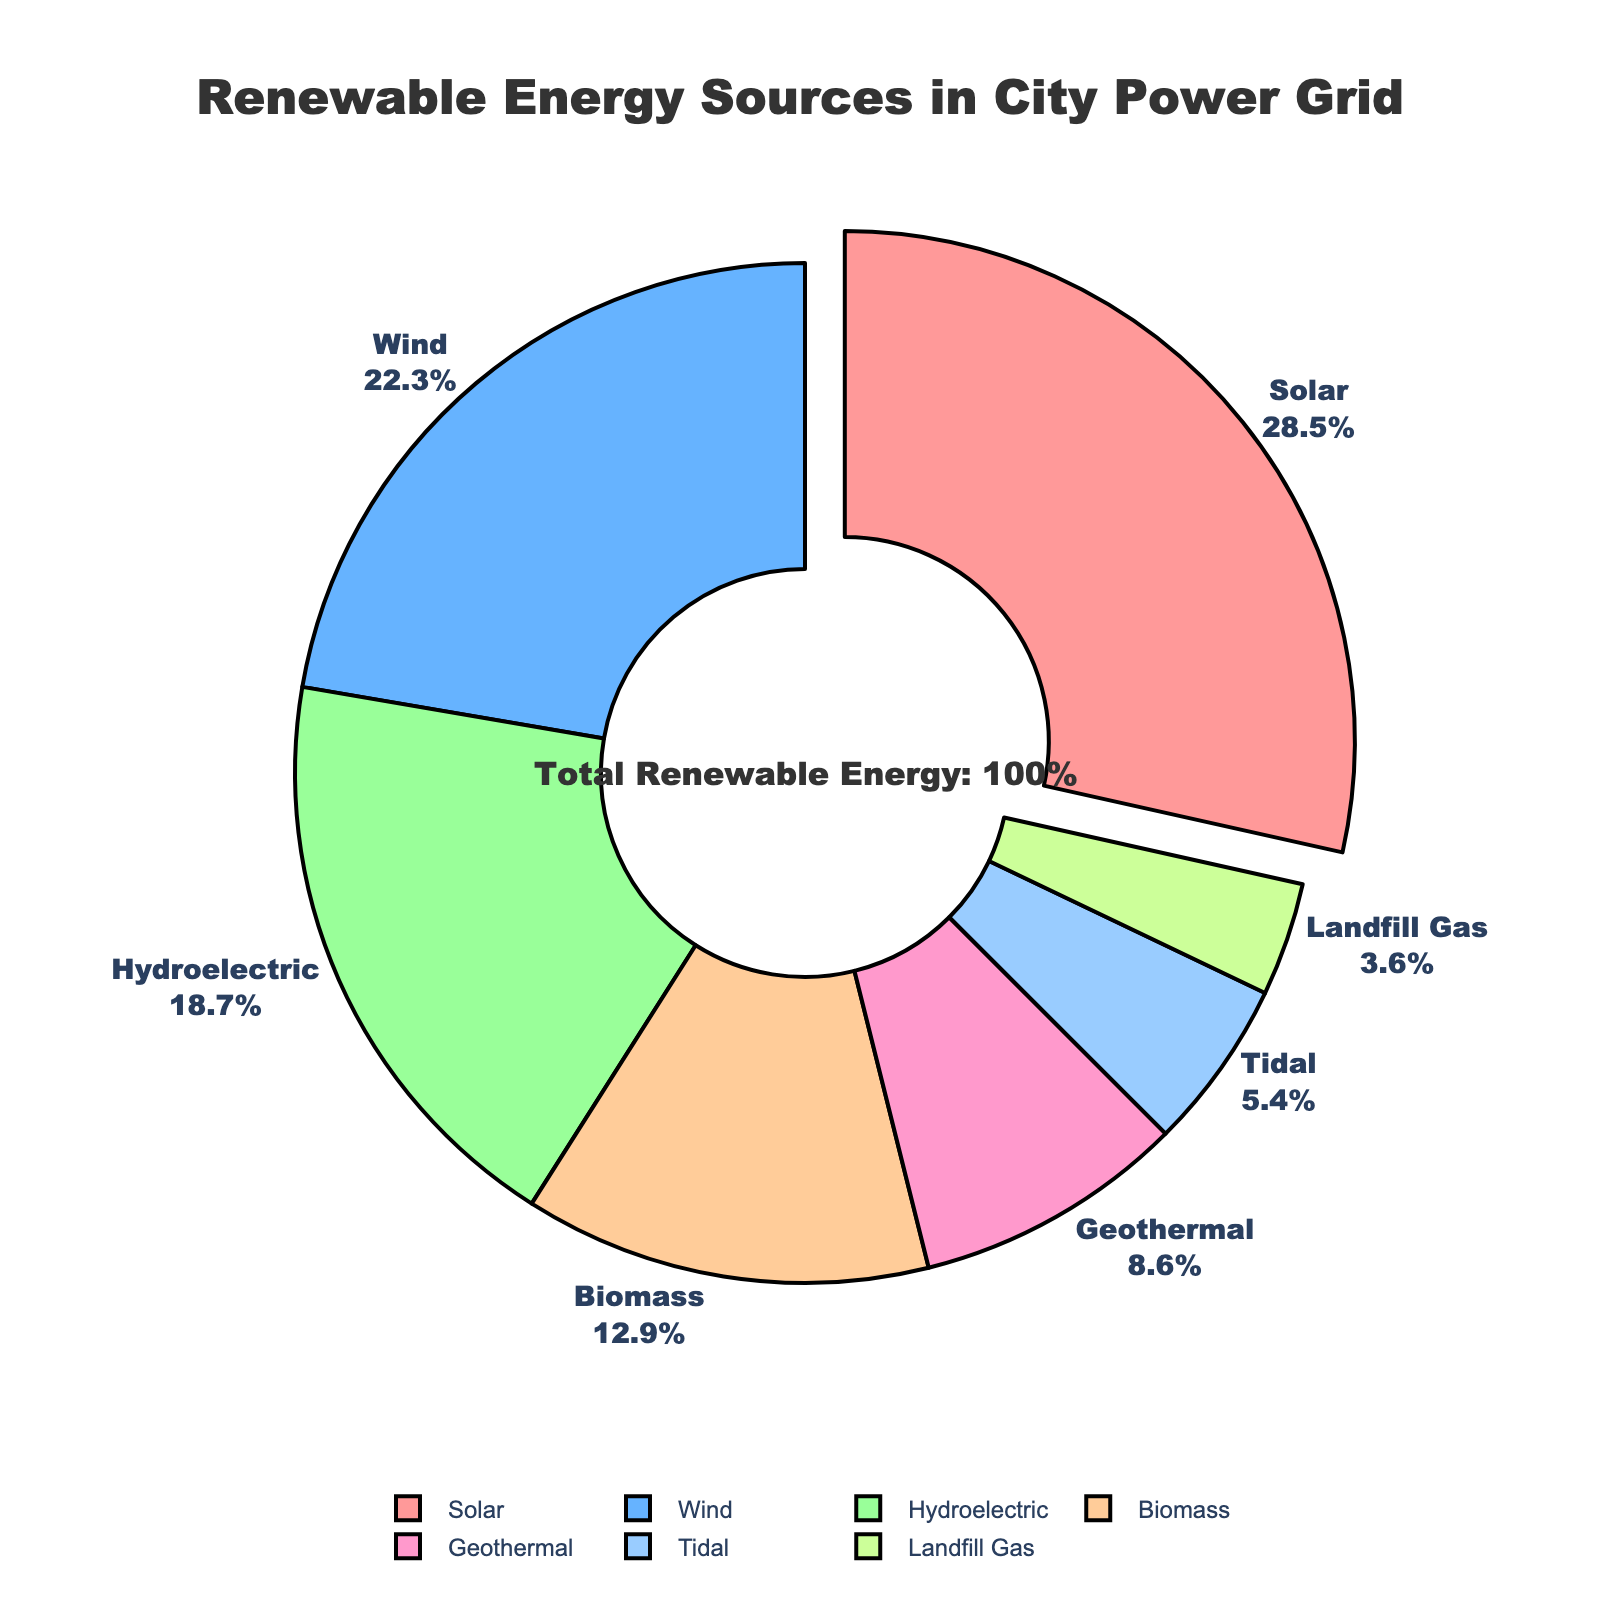what is the largest energy source in the city's power grid? The pie chart visually highlights the largest energy source by pulling it out from the rest. According to the chart, the largest segment is solar, which is also indicated by the highest percentage.
Answer: Solar which renewable energy source contributes the least to the city's power grid? By looking at the pie chart and finding the smallest segment, we can determine that landfill gas has the smallest percentage at 3.6%.
Answer: Landfill Gas how do the contributions of wind and biomass energy compare? From the pie chart, we see that wind energy contributes 22.3% while biomass contributes 12.9%. Comparing these, wind energy has a higher contribution than biomass.
Answer: Wind contributes more what is the combined percentage of hydroelectric and tidal energy sources? To find the sum, we add the percentages of hydroelectric (18.7%) and tidal (5.4%). Therefore, the combined percentage is 18.7% + 5.4%.
Answer: 24.1% if geothermal energy was to double its contribution, what percentage would it represent in the pie chart? Geothermal currently contributes 8.6%. If it doubles, the contribution will be 8.6% * 2. This results in a doubled contribution of 17.2%.
Answer: 17.2% is solar energy's contribution more than the combined contributions of geothermal and tidal energy? Solar energy contributes 28.5%. The combined contribution of geothermal (8.6%) and tidal (5.4%) is 8.6% + 5.4% = 14%. Since 28.5% is greater than 14%, solar energy contributes more.
Answer: Yes what is the color of the segment representing hydroelectric energy? The pie chart uses different colors for each segment. The color for hydroelectric energy is green.
Answer: Green which energy sources have contributions that are within a 5% range of each other? By examining the percentages, we see that wind (22.3%), hydroelectric (18.7%), and biomass (12.9%) fall within a 5% range of each other. Wind and hydroelectric are within 5% as well as hydroelectric and biomass.
Answer: Wind and Hydroelectric; Hydroelectric and Biomass 